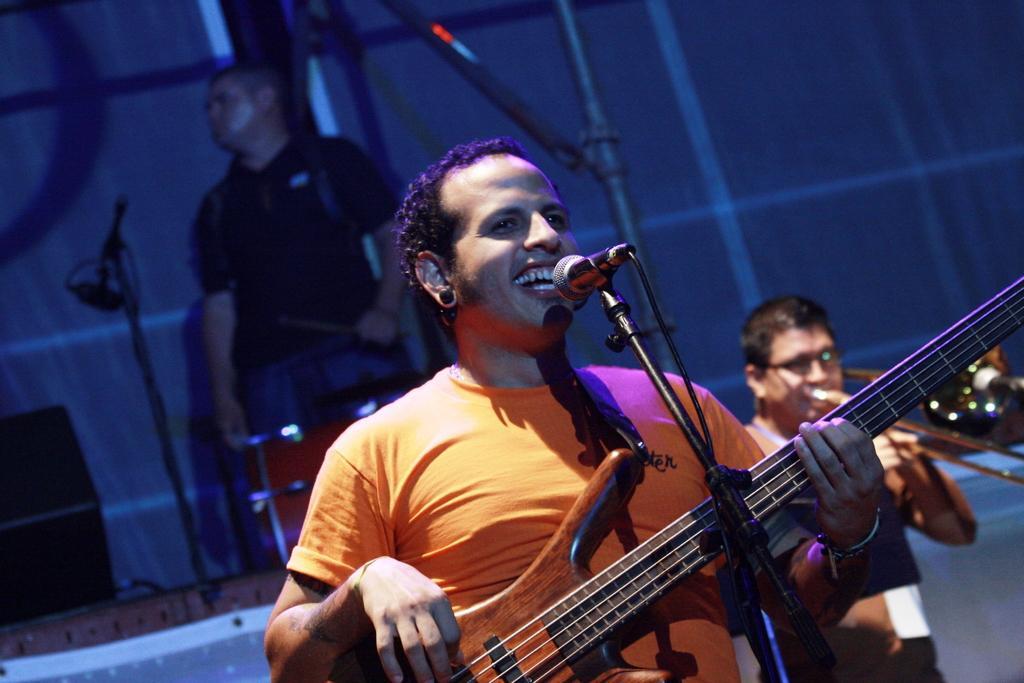Can you describe this image briefly? There is a man standing, singing and playing guitar. There is a mic, in front of him. In the background there is another person. He is playing an instrument. Backside to him, there is another person. He is playing drums. 